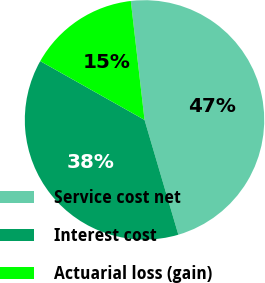Convert chart to OTSL. <chart><loc_0><loc_0><loc_500><loc_500><pie_chart><fcel>Service cost net<fcel>Interest cost<fcel>Actuarial loss (gain)<nl><fcel>47.27%<fcel>37.73%<fcel>15.0%<nl></chart> 